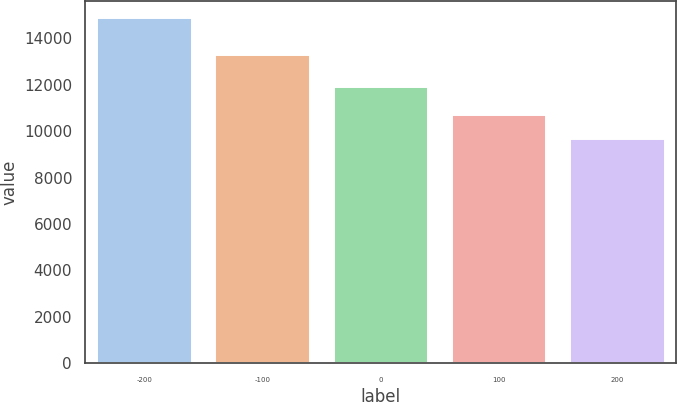<chart> <loc_0><loc_0><loc_500><loc_500><bar_chart><fcel>-200<fcel>-100<fcel>0<fcel>100<fcel>200<nl><fcel>14847<fcel>13261<fcel>11888<fcel>10694<fcel>9650<nl></chart> 